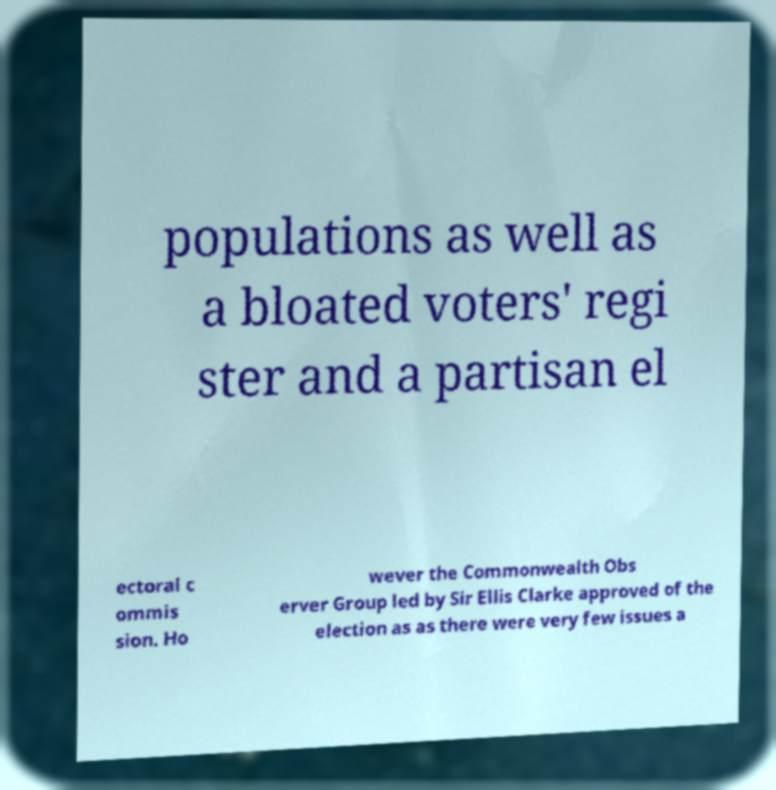Could you assist in decoding the text presented in this image and type it out clearly? populations as well as a bloated voters' regi ster and a partisan el ectoral c ommis sion. Ho wever the Commonwealth Obs erver Group led by Sir Ellis Clarke approved of the election as as there were very few issues a 